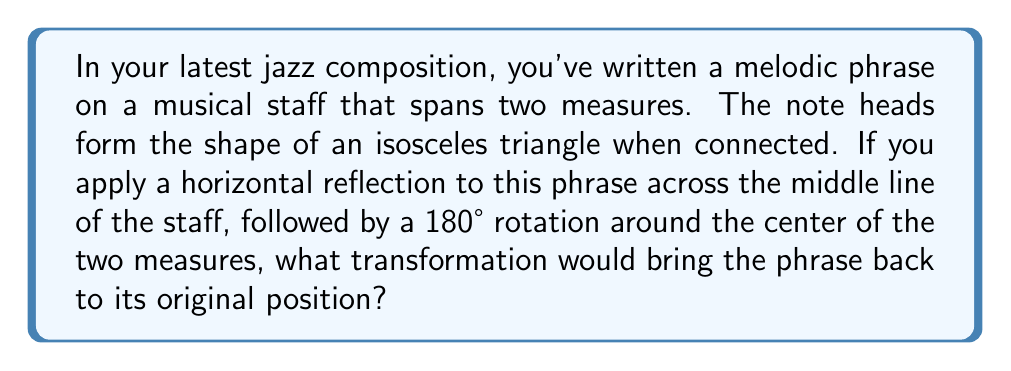Help me with this question. Let's approach this step-by-step:

1) First, let's consider the initial transformation:
   a) Horizontal reflection across the middle line of the staff
   b) 180° rotation around the center of the two measures

2) To find the transformation that brings the phrase back to its original position, we need to apply the inverse of these transformations in reverse order.

3) The inverse of a 180° rotation is another 180° rotation around the same point.

4) The inverse of a reflection is the same reflection.

5) Therefore, to undo the transformations, we need to:
   a) Rotate 180° around the center of the two measures
   b) Reflect horizontally across the middle line of the staff

6) In transformational geometry, when we apply a reflection followed by a rotation of 180°, this is equivalent to a glide reflection.

7) A glide reflection is a composition of a reflection and a translation parallel to the line of reflection.

8) In this case, the translation would be horizontal and equal to the width of the two measures.

9) Therefore, applying a glide reflection with the line of reflection being the middle line of the staff and the translation being the width of the two measures would bring the phrase back to its original position.
Answer: Glide reflection 